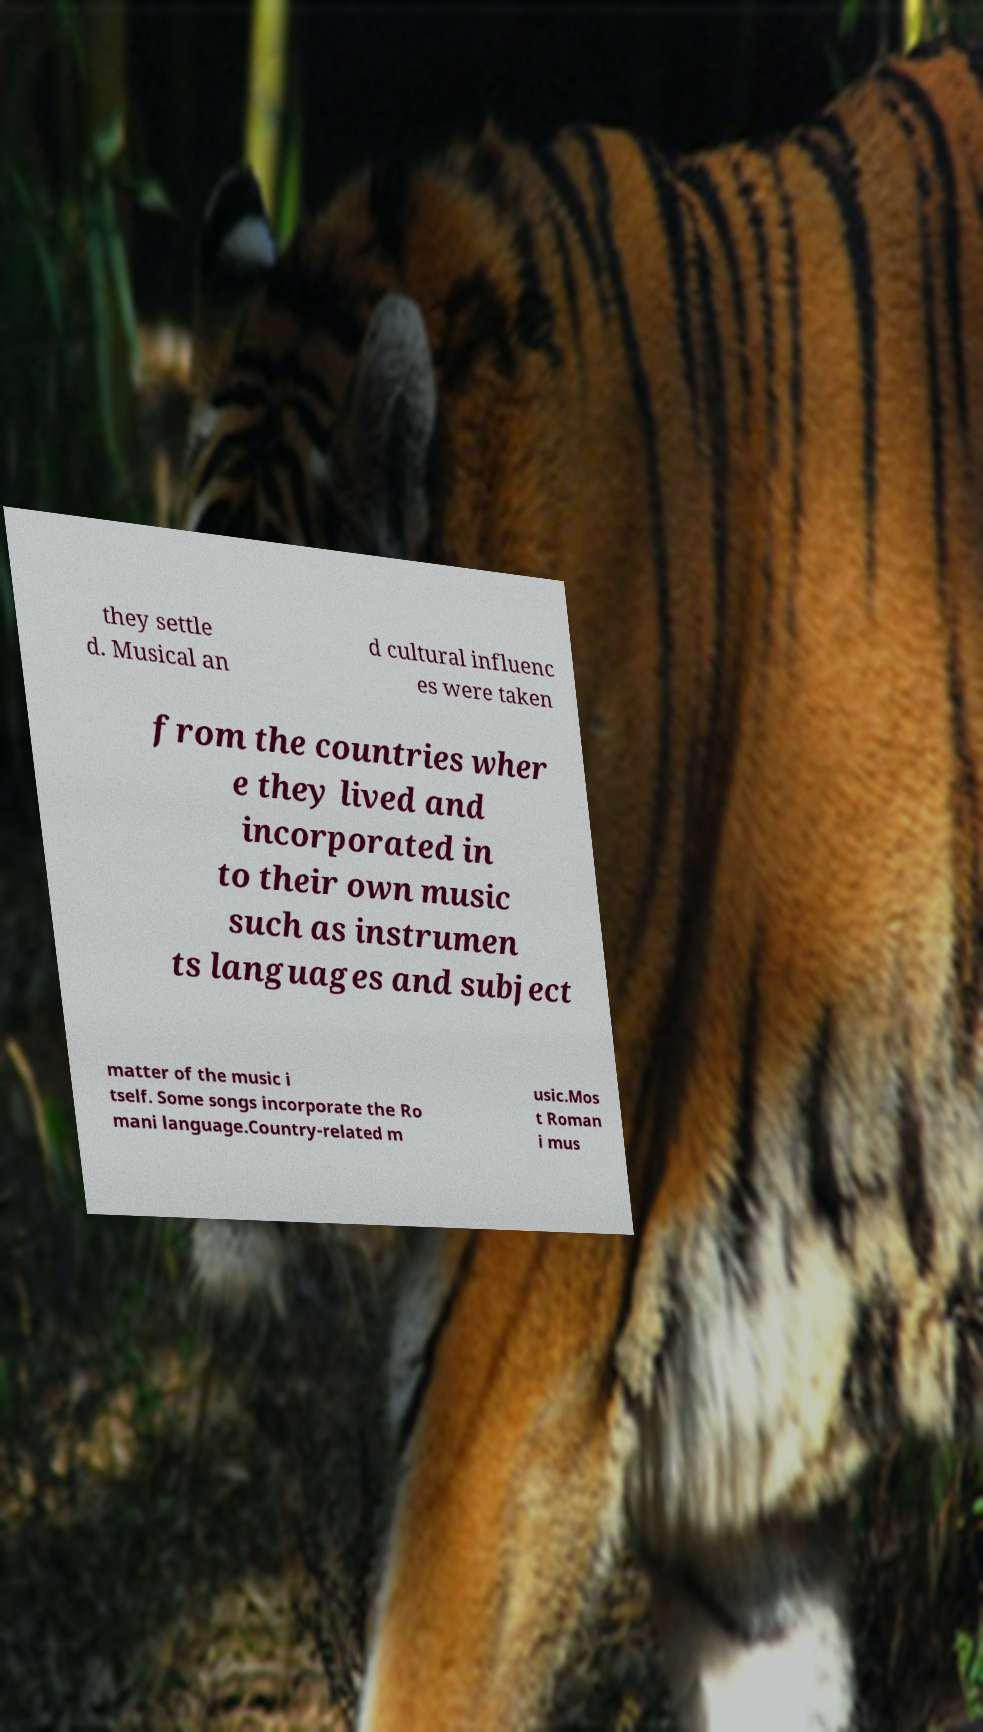Can you read and provide the text displayed in the image?This photo seems to have some interesting text. Can you extract and type it out for me? they settle d. Musical an d cultural influenc es were taken from the countries wher e they lived and incorporated in to their own music such as instrumen ts languages and subject matter of the music i tself. Some songs incorporate the Ro mani language.Country-related m usic.Mos t Roman i mus 